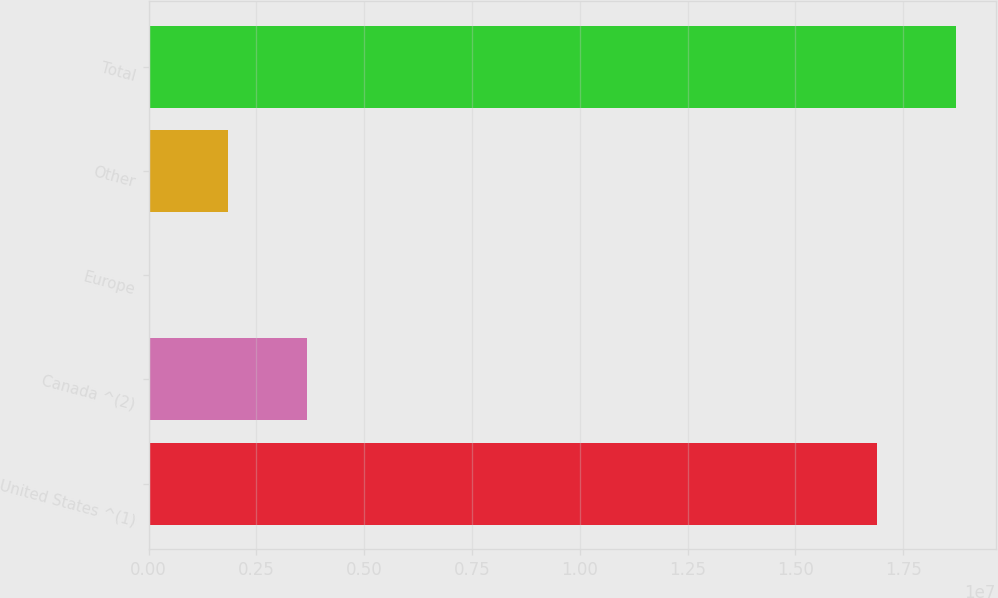<chart> <loc_0><loc_0><loc_500><loc_500><bar_chart><fcel>United States ^(1)<fcel>Canada ^(2)<fcel>Europe<fcel>Other<fcel>Total<nl><fcel>1.68945e+07<fcel>3.66535e+06<fcel>25011<fcel>1.84518e+06<fcel>1.87146e+07<nl></chart> 